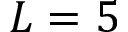Convert formula to latex. <formula><loc_0><loc_0><loc_500><loc_500>L = 5</formula> 